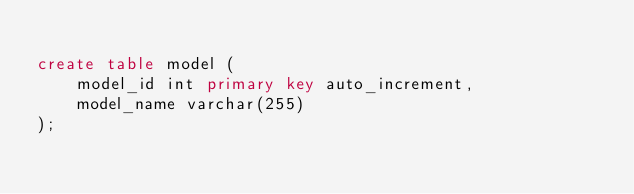Convert code to text. <code><loc_0><loc_0><loc_500><loc_500><_SQL_>
create table model (
    model_id int primary key auto_increment,
    model_name varchar(255)
);
</code> 